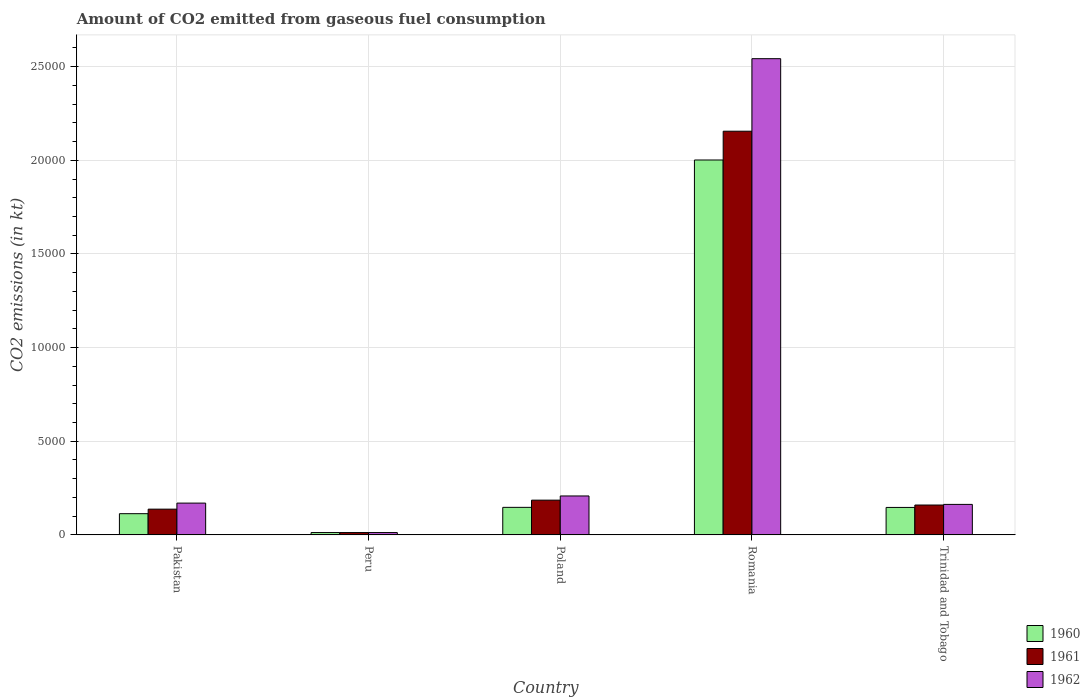Are the number of bars on each tick of the X-axis equal?
Make the answer very short. Yes. How many bars are there on the 5th tick from the right?
Make the answer very short. 3. What is the amount of CO2 emitted in 1960 in Poland?
Provide a short and direct response. 1470.47. Across all countries, what is the maximum amount of CO2 emitted in 1962?
Provide a short and direct response. 2.54e+04. Across all countries, what is the minimum amount of CO2 emitted in 1960?
Make the answer very short. 124.68. In which country was the amount of CO2 emitted in 1962 maximum?
Offer a terse response. Romania. What is the total amount of CO2 emitted in 1961 in the graph?
Your answer should be very brief. 2.65e+04. What is the difference between the amount of CO2 emitted in 1962 in Peru and that in Romania?
Your answer should be very brief. -2.53e+04. What is the difference between the amount of CO2 emitted in 1961 in Pakistan and the amount of CO2 emitted in 1962 in Romania?
Offer a terse response. -2.41e+04. What is the average amount of CO2 emitted in 1961 per country?
Your response must be concise. 5301.02. What is the difference between the amount of CO2 emitted of/in 1962 and amount of CO2 emitted of/in 1960 in Poland?
Your answer should be compact. 608.72. What is the ratio of the amount of CO2 emitted in 1962 in Peru to that in Romania?
Provide a succinct answer. 0. Is the difference between the amount of CO2 emitted in 1962 in Peru and Romania greater than the difference between the amount of CO2 emitted in 1960 in Peru and Romania?
Offer a very short reply. No. What is the difference between the highest and the second highest amount of CO2 emitted in 1962?
Your answer should be compact. -2.37e+04. What is the difference between the highest and the lowest amount of CO2 emitted in 1962?
Keep it short and to the point. 2.53e+04. In how many countries, is the amount of CO2 emitted in 1962 greater than the average amount of CO2 emitted in 1962 taken over all countries?
Provide a succinct answer. 1. Is the sum of the amount of CO2 emitted in 1962 in Peru and Romania greater than the maximum amount of CO2 emitted in 1961 across all countries?
Your response must be concise. Yes. What does the 3rd bar from the right in Peru represents?
Your response must be concise. 1960. Does the graph contain any zero values?
Ensure brevity in your answer.  No. Does the graph contain grids?
Your answer should be compact. Yes. Where does the legend appear in the graph?
Your answer should be compact. Bottom right. How many legend labels are there?
Ensure brevity in your answer.  3. How are the legend labels stacked?
Your answer should be compact. Vertical. What is the title of the graph?
Keep it short and to the point. Amount of CO2 emitted from gaseous fuel consumption. Does "1987" appear as one of the legend labels in the graph?
Keep it short and to the point. No. What is the label or title of the Y-axis?
Your response must be concise. CO2 emissions (in kt). What is the CO2 emissions (in kt) of 1960 in Pakistan?
Your response must be concise. 1133.1. What is the CO2 emissions (in kt) of 1961 in Pakistan?
Keep it short and to the point. 1375.12. What is the CO2 emissions (in kt) in 1962 in Pakistan?
Provide a short and direct response. 1697.82. What is the CO2 emissions (in kt) of 1960 in Peru?
Give a very brief answer. 124.68. What is the CO2 emissions (in kt) of 1961 in Peru?
Your response must be concise. 124.68. What is the CO2 emissions (in kt) in 1962 in Peru?
Ensure brevity in your answer.  124.68. What is the CO2 emissions (in kt) of 1960 in Poland?
Keep it short and to the point. 1470.47. What is the CO2 emissions (in kt) of 1961 in Poland?
Keep it short and to the point. 1855.5. What is the CO2 emissions (in kt) of 1962 in Poland?
Make the answer very short. 2079.19. What is the CO2 emissions (in kt) in 1960 in Romania?
Provide a succinct answer. 2.00e+04. What is the CO2 emissions (in kt) of 1961 in Romania?
Give a very brief answer. 2.16e+04. What is the CO2 emissions (in kt) in 1962 in Romania?
Provide a short and direct response. 2.54e+04. What is the CO2 emissions (in kt) of 1960 in Trinidad and Tobago?
Provide a succinct answer. 1466.8. What is the CO2 emissions (in kt) in 1961 in Trinidad and Tobago?
Offer a very short reply. 1595.14. What is the CO2 emissions (in kt) in 1962 in Trinidad and Tobago?
Make the answer very short. 1628.15. Across all countries, what is the maximum CO2 emissions (in kt) of 1960?
Your answer should be very brief. 2.00e+04. Across all countries, what is the maximum CO2 emissions (in kt) in 1961?
Give a very brief answer. 2.16e+04. Across all countries, what is the maximum CO2 emissions (in kt) in 1962?
Offer a terse response. 2.54e+04. Across all countries, what is the minimum CO2 emissions (in kt) in 1960?
Provide a succinct answer. 124.68. Across all countries, what is the minimum CO2 emissions (in kt) of 1961?
Ensure brevity in your answer.  124.68. Across all countries, what is the minimum CO2 emissions (in kt) in 1962?
Your answer should be compact. 124.68. What is the total CO2 emissions (in kt) of 1960 in the graph?
Provide a short and direct response. 2.42e+04. What is the total CO2 emissions (in kt) of 1961 in the graph?
Provide a succinct answer. 2.65e+04. What is the total CO2 emissions (in kt) in 1962 in the graph?
Your answer should be very brief. 3.10e+04. What is the difference between the CO2 emissions (in kt) in 1960 in Pakistan and that in Peru?
Ensure brevity in your answer.  1008.42. What is the difference between the CO2 emissions (in kt) in 1961 in Pakistan and that in Peru?
Provide a short and direct response. 1250.45. What is the difference between the CO2 emissions (in kt) of 1962 in Pakistan and that in Peru?
Offer a very short reply. 1573.14. What is the difference between the CO2 emissions (in kt) in 1960 in Pakistan and that in Poland?
Your answer should be very brief. -337.36. What is the difference between the CO2 emissions (in kt) of 1961 in Pakistan and that in Poland?
Your answer should be very brief. -480.38. What is the difference between the CO2 emissions (in kt) in 1962 in Pakistan and that in Poland?
Keep it short and to the point. -381.37. What is the difference between the CO2 emissions (in kt) of 1960 in Pakistan and that in Romania?
Give a very brief answer. -1.89e+04. What is the difference between the CO2 emissions (in kt) of 1961 in Pakistan and that in Romania?
Ensure brevity in your answer.  -2.02e+04. What is the difference between the CO2 emissions (in kt) in 1962 in Pakistan and that in Romania?
Keep it short and to the point. -2.37e+04. What is the difference between the CO2 emissions (in kt) in 1960 in Pakistan and that in Trinidad and Tobago?
Your answer should be compact. -333.7. What is the difference between the CO2 emissions (in kt) in 1961 in Pakistan and that in Trinidad and Tobago?
Your response must be concise. -220.02. What is the difference between the CO2 emissions (in kt) of 1962 in Pakistan and that in Trinidad and Tobago?
Offer a very short reply. 69.67. What is the difference between the CO2 emissions (in kt) in 1960 in Peru and that in Poland?
Make the answer very short. -1345.79. What is the difference between the CO2 emissions (in kt) in 1961 in Peru and that in Poland?
Ensure brevity in your answer.  -1730.82. What is the difference between the CO2 emissions (in kt) of 1962 in Peru and that in Poland?
Provide a short and direct response. -1954.51. What is the difference between the CO2 emissions (in kt) of 1960 in Peru and that in Romania?
Offer a very short reply. -1.99e+04. What is the difference between the CO2 emissions (in kt) in 1961 in Peru and that in Romania?
Give a very brief answer. -2.14e+04. What is the difference between the CO2 emissions (in kt) of 1962 in Peru and that in Romania?
Ensure brevity in your answer.  -2.53e+04. What is the difference between the CO2 emissions (in kt) of 1960 in Peru and that in Trinidad and Tobago?
Your answer should be very brief. -1342.12. What is the difference between the CO2 emissions (in kt) of 1961 in Peru and that in Trinidad and Tobago?
Give a very brief answer. -1470.47. What is the difference between the CO2 emissions (in kt) of 1962 in Peru and that in Trinidad and Tobago?
Provide a succinct answer. -1503.47. What is the difference between the CO2 emissions (in kt) of 1960 in Poland and that in Romania?
Your response must be concise. -1.85e+04. What is the difference between the CO2 emissions (in kt) of 1961 in Poland and that in Romania?
Provide a short and direct response. -1.97e+04. What is the difference between the CO2 emissions (in kt) of 1962 in Poland and that in Romania?
Provide a short and direct response. -2.33e+04. What is the difference between the CO2 emissions (in kt) of 1960 in Poland and that in Trinidad and Tobago?
Offer a terse response. 3.67. What is the difference between the CO2 emissions (in kt) of 1961 in Poland and that in Trinidad and Tobago?
Your answer should be very brief. 260.36. What is the difference between the CO2 emissions (in kt) of 1962 in Poland and that in Trinidad and Tobago?
Your answer should be compact. 451.04. What is the difference between the CO2 emissions (in kt) of 1960 in Romania and that in Trinidad and Tobago?
Your answer should be compact. 1.86e+04. What is the difference between the CO2 emissions (in kt) in 1961 in Romania and that in Trinidad and Tobago?
Make the answer very short. 2.00e+04. What is the difference between the CO2 emissions (in kt) of 1962 in Romania and that in Trinidad and Tobago?
Give a very brief answer. 2.38e+04. What is the difference between the CO2 emissions (in kt) of 1960 in Pakistan and the CO2 emissions (in kt) of 1961 in Peru?
Give a very brief answer. 1008.42. What is the difference between the CO2 emissions (in kt) of 1960 in Pakistan and the CO2 emissions (in kt) of 1962 in Peru?
Give a very brief answer. 1008.42. What is the difference between the CO2 emissions (in kt) in 1961 in Pakistan and the CO2 emissions (in kt) in 1962 in Peru?
Offer a terse response. 1250.45. What is the difference between the CO2 emissions (in kt) in 1960 in Pakistan and the CO2 emissions (in kt) in 1961 in Poland?
Provide a short and direct response. -722.4. What is the difference between the CO2 emissions (in kt) of 1960 in Pakistan and the CO2 emissions (in kt) of 1962 in Poland?
Ensure brevity in your answer.  -946.09. What is the difference between the CO2 emissions (in kt) of 1961 in Pakistan and the CO2 emissions (in kt) of 1962 in Poland?
Your response must be concise. -704.06. What is the difference between the CO2 emissions (in kt) in 1960 in Pakistan and the CO2 emissions (in kt) in 1961 in Romania?
Provide a short and direct response. -2.04e+04. What is the difference between the CO2 emissions (in kt) in 1960 in Pakistan and the CO2 emissions (in kt) in 1962 in Romania?
Your response must be concise. -2.43e+04. What is the difference between the CO2 emissions (in kt) of 1961 in Pakistan and the CO2 emissions (in kt) of 1962 in Romania?
Ensure brevity in your answer.  -2.41e+04. What is the difference between the CO2 emissions (in kt) of 1960 in Pakistan and the CO2 emissions (in kt) of 1961 in Trinidad and Tobago?
Give a very brief answer. -462.04. What is the difference between the CO2 emissions (in kt) of 1960 in Pakistan and the CO2 emissions (in kt) of 1962 in Trinidad and Tobago?
Make the answer very short. -495.05. What is the difference between the CO2 emissions (in kt) in 1961 in Pakistan and the CO2 emissions (in kt) in 1962 in Trinidad and Tobago?
Your answer should be very brief. -253.02. What is the difference between the CO2 emissions (in kt) in 1960 in Peru and the CO2 emissions (in kt) in 1961 in Poland?
Provide a succinct answer. -1730.82. What is the difference between the CO2 emissions (in kt) in 1960 in Peru and the CO2 emissions (in kt) in 1962 in Poland?
Offer a very short reply. -1954.51. What is the difference between the CO2 emissions (in kt) in 1961 in Peru and the CO2 emissions (in kt) in 1962 in Poland?
Your answer should be very brief. -1954.51. What is the difference between the CO2 emissions (in kt) in 1960 in Peru and the CO2 emissions (in kt) in 1961 in Romania?
Provide a short and direct response. -2.14e+04. What is the difference between the CO2 emissions (in kt) in 1960 in Peru and the CO2 emissions (in kt) in 1962 in Romania?
Provide a succinct answer. -2.53e+04. What is the difference between the CO2 emissions (in kt) of 1961 in Peru and the CO2 emissions (in kt) of 1962 in Romania?
Provide a short and direct response. -2.53e+04. What is the difference between the CO2 emissions (in kt) in 1960 in Peru and the CO2 emissions (in kt) in 1961 in Trinidad and Tobago?
Provide a succinct answer. -1470.47. What is the difference between the CO2 emissions (in kt) in 1960 in Peru and the CO2 emissions (in kt) in 1962 in Trinidad and Tobago?
Your response must be concise. -1503.47. What is the difference between the CO2 emissions (in kt) of 1961 in Peru and the CO2 emissions (in kt) of 1962 in Trinidad and Tobago?
Ensure brevity in your answer.  -1503.47. What is the difference between the CO2 emissions (in kt) of 1960 in Poland and the CO2 emissions (in kt) of 1961 in Romania?
Keep it short and to the point. -2.01e+04. What is the difference between the CO2 emissions (in kt) of 1960 in Poland and the CO2 emissions (in kt) of 1962 in Romania?
Your answer should be compact. -2.40e+04. What is the difference between the CO2 emissions (in kt) in 1961 in Poland and the CO2 emissions (in kt) in 1962 in Romania?
Your answer should be compact. -2.36e+04. What is the difference between the CO2 emissions (in kt) of 1960 in Poland and the CO2 emissions (in kt) of 1961 in Trinidad and Tobago?
Make the answer very short. -124.68. What is the difference between the CO2 emissions (in kt) of 1960 in Poland and the CO2 emissions (in kt) of 1962 in Trinidad and Tobago?
Make the answer very short. -157.68. What is the difference between the CO2 emissions (in kt) of 1961 in Poland and the CO2 emissions (in kt) of 1962 in Trinidad and Tobago?
Provide a short and direct response. 227.35. What is the difference between the CO2 emissions (in kt) of 1960 in Romania and the CO2 emissions (in kt) of 1961 in Trinidad and Tobago?
Your answer should be very brief. 1.84e+04. What is the difference between the CO2 emissions (in kt) in 1960 in Romania and the CO2 emissions (in kt) in 1962 in Trinidad and Tobago?
Offer a very short reply. 1.84e+04. What is the difference between the CO2 emissions (in kt) in 1961 in Romania and the CO2 emissions (in kt) in 1962 in Trinidad and Tobago?
Give a very brief answer. 1.99e+04. What is the average CO2 emissions (in kt) of 1960 per country?
Give a very brief answer. 4842.64. What is the average CO2 emissions (in kt) of 1961 per country?
Your answer should be compact. 5301.02. What is the average CO2 emissions (in kt) of 1962 per country?
Ensure brevity in your answer.  6191.36. What is the difference between the CO2 emissions (in kt) of 1960 and CO2 emissions (in kt) of 1961 in Pakistan?
Give a very brief answer. -242.02. What is the difference between the CO2 emissions (in kt) in 1960 and CO2 emissions (in kt) in 1962 in Pakistan?
Provide a succinct answer. -564.72. What is the difference between the CO2 emissions (in kt) in 1961 and CO2 emissions (in kt) in 1962 in Pakistan?
Your answer should be very brief. -322.7. What is the difference between the CO2 emissions (in kt) in 1960 and CO2 emissions (in kt) in 1961 in Peru?
Make the answer very short. 0. What is the difference between the CO2 emissions (in kt) of 1961 and CO2 emissions (in kt) of 1962 in Peru?
Your response must be concise. 0. What is the difference between the CO2 emissions (in kt) in 1960 and CO2 emissions (in kt) in 1961 in Poland?
Provide a short and direct response. -385.04. What is the difference between the CO2 emissions (in kt) of 1960 and CO2 emissions (in kt) of 1962 in Poland?
Your answer should be very brief. -608.72. What is the difference between the CO2 emissions (in kt) in 1961 and CO2 emissions (in kt) in 1962 in Poland?
Your answer should be compact. -223.69. What is the difference between the CO2 emissions (in kt) of 1960 and CO2 emissions (in kt) of 1961 in Romania?
Provide a short and direct response. -1536.47. What is the difference between the CO2 emissions (in kt) of 1960 and CO2 emissions (in kt) of 1962 in Romania?
Provide a succinct answer. -5408.82. What is the difference between the CO2 emissions (in kt) in 1961 and CO2 emissions (in kt) in 1962 in Romania?
Offer a very short reply. -3872.35. What is the difference between the CO2 emissions (in kt) in 1960 and CO2 emissions (in kt) in 1961 in Trinidad and Tobago?
Your answer should be compact. -128.34. What is the difference between the CO2 emissions (in kt) in 1960 and CO2 emissions (in kt) in 1962 in Trinidad and Tobago?
Ensure brevity in your answer.  -161.35. What is the difference between the CO2 emissions (in kt) of 1961 and CO2 emissions (in kt) of 1962 in Trinidad and Tobago?
Offer a terse response. -33. What is the ratio of the CO2 emissions (in kt) in 1960 in Pakistan to that in Peru?
Your answer should be compact. 9.09. What is the ratio of the CO2 emissions (in kt) in 1961 in Pakistan to that in Peru?
Provide a short and direct response. 11.03. What is the ratio of the CO2 emissions (in kt) of 1962 in Pakistan to that in Peru?
Give a very brief answer. 13.62. What is the ratio of the CO2 emissions (in kt) of 1960 in Pakistan to that in Poland?
Keep it short and to the point. 0.77. What is the ratio of the CO2 emissions (in kt) in 1961 in Pakistan to that in Poland?
Provide a short and direct response. 0.74. What is the ratio of the CO2 emissions (in kt) in 1962 in Pakistan to that in Poland?
Offer a terse response. 0.82. What is the ratio of the CO2 emissions (in kt) in 1960 in Pakistan to that in Romania?
Provide a succinct answer. 0.06. What is the ratio of the CO2 emissions (in kt) in 1961 in Pakistan to that in Romania?
Provide a short and direct response. 0.06. What is the ratio of the CO2 emissions (in kt) in 1962 in Pakistan to that in Romania?
Provide a short and direct response. 0.07. What is the ratio of the CO2 emissions (in kt) in 1960 in Pakistan to that in Trinidad and Tobago?
Provide a succinct answer. 0.77. What is the ratio of the CO2 emissions (in kt) of 1961 in Pakistan to that in Trinidad and Tobago?
Keep it short and to the point. 0.86. What is the ratio of the CO2 emissions (in kt) in 1962 in Pakistan to that in Trinidad and Tobago?
Ensure brevity in your answer.  1.04. What is the ratio of the CO2 emissions (in kt) in 1960 in Peru to that in Poland?
Ensure brevity in your answer.  0.08. What is the ratio of the CO2 emissions (in kt) in 1961 in Peru to that in Poland?
Your answer should be compact. 0.07. What is the ratio of the CO2 emissions (in kt) of 1960 in Peru to that in Romania?
Offer a terse response. 0.01. What is the ratio of the CO2 emissions (in kt) in 1961 in Peru to that in Romania?
Provide a short and direct response. 0.01. What is the ratio of the CO2 emissions (in kt) in 1962 in Peru to that in Romania?
Make the answer very short. 0. What is the ratio of the CO2 emissions (in kt) of 1960 in Peru to that in Trinidad and Tobago?
Offer a very short reply. 0.09. What is the ratio of the CO2 emissions (in kt) in 1961 in Peru to that in Trinidad and Tobago?
Keep it short and to the point. 0.08. What is the ratio of the CO2 emissions (in kt) of 1962 in Peru to that in Trinidad and Tobago?
Provide a succinct answer. 0.08. What is the ratio of the CO2 emissions (in kt) of 1960 in Poland to that in Romania?
Keep it short and to the point. 0.07. What is the ratio of the CO2 emissions (in kt) of 1961 in Poland to that in Romania?
Your answer should be compact. 0.09. What is the ratio of the CO2 emissions (in kt) of 1962 in Poland to that in Romania?
Provide a succinct answer. 0.08. What is the ratio of the CO2 emissions (in kt) in 1960 in Poland to that in Trinidad and Tobago?
Offer a very short reply. 1. What is the ratio of the CO2 emissions (in kt) of 1961 in Poland to that in Trinidad and Tobago?
Provide a succinct answer. 1.16. What is the ratio of the CO2 emissions (in kt) of 1962 in Poland to that in Trinidad and Tobago?
Offer a terse response. 1.28. What is the ratio of the CO2 emissions (in kt) in 1960 in Romania to that in Trinidad and Tobago?
Keep it short and to the point. 13.65. What is the ratio of the CO2 emissions (in kt) of 1961 in Romania to that in Trinidad and Tobago?
Provide a short and direct response. 13.51. What is the ratio of the CO2 emissions (in kt) of 1962 in Romania to that in Trinidad and Tobago?
Give a very brief answer. 15.62. What is the difference between the highest and the second highest CO2 emissions (in kt) in 1960?
Give a very brief answer. 1.85e+04. What is the difference between the highest and the second highest CO2 emissions (in kt) in 1961?
Ensure brevity in your answer.  1.97e+04. What is the difference between the highest and the second highest CO2 emissions (in kt) in 1962?
Provide a short and direct response. 2.33e+04. What is the difference between the highest and the lowest CO2 emissions (in kt) of 1960?
Ensure brevity in your answer.  1.99e+04. What is the difference between the highest and the lowest CO2 emissions (in kt) of 1961?
Your answer should be very brief. 2.14e+04. What is the difference between the highest and the lowest CO2 emissions (in kt) in 1962?
Give a very brief answer. 2.53e+04. 